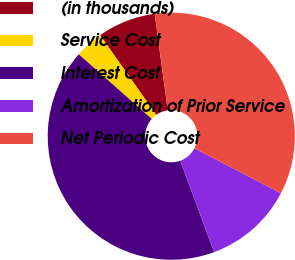Convert chart to OTSL. <chart><loc_0><loc_0><loc_500><loc_500><pie_chart><fcel>(in thousands)<fcel>Service Cost<fcel>Interest Cost<fcel>Amortization of Prior Service<fcel>Net Periodic Cost<nl><fcel>7.62%<fcel>3.7%<fcel>42.16%<fcel>11.74%<fcel>34.79%<nl></chart> 